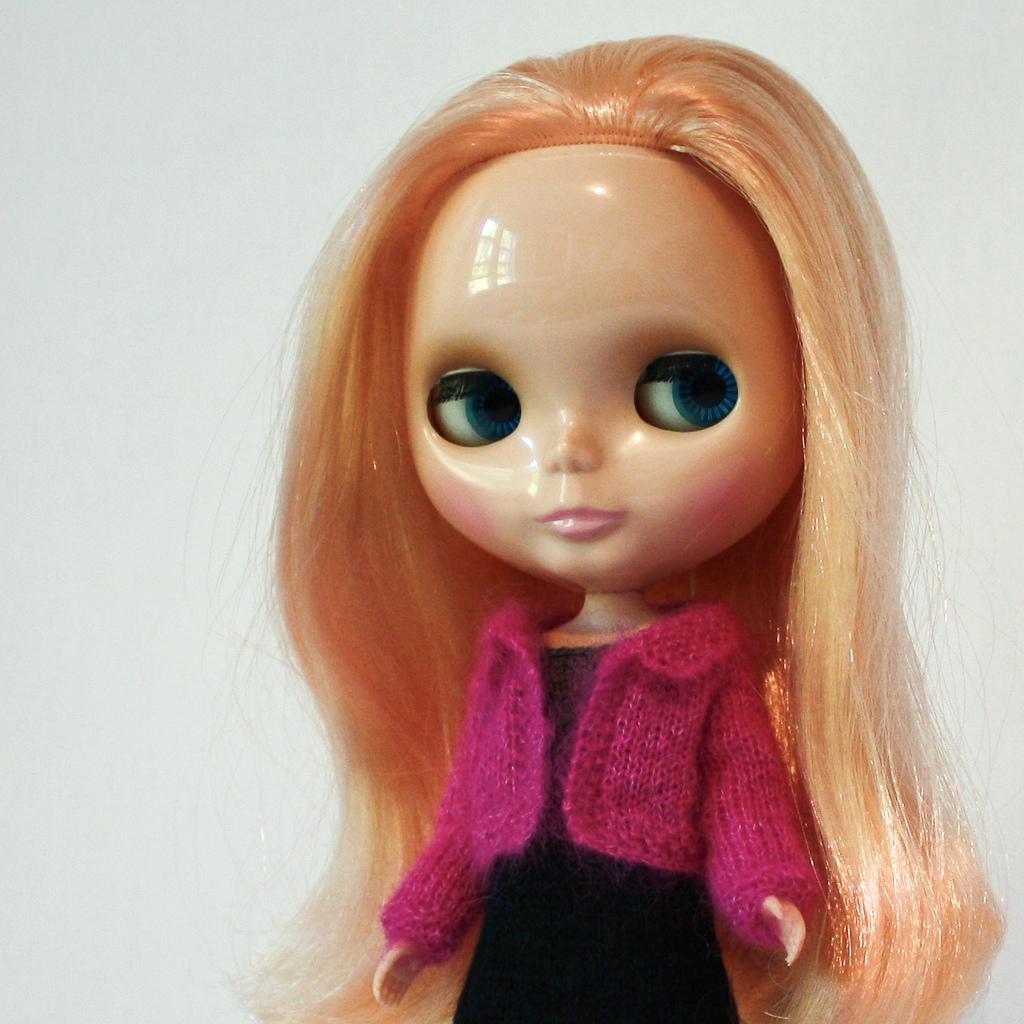Can you describe this image briefly? In this image we can see a doll. On the backside we can see a wall. 